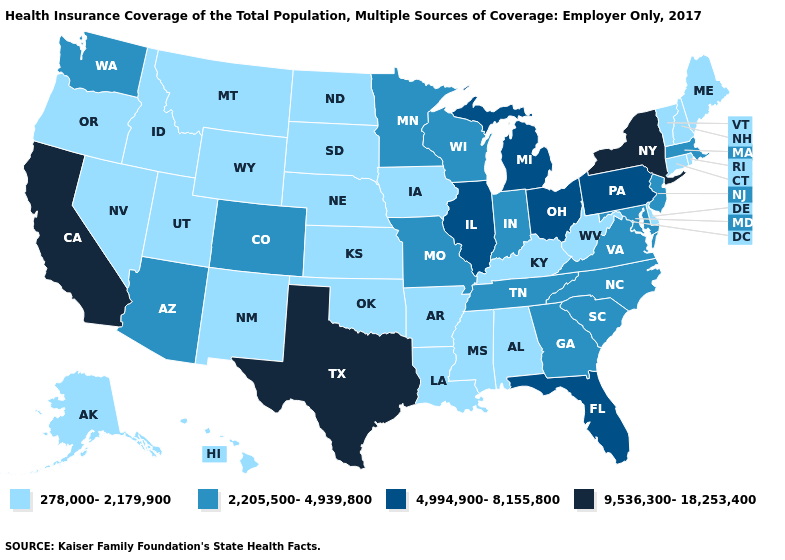Which states have the lowest value in the West?
Short answer required. Alaska, Hawaii, Idaho, Montana, Nevada, New Mexico, Oregon, Utah, Wyoming. Does Washington have the lowest value in the West?
Short answer required. No. Does Alaska have the highest value in the USA?
Keep it brief. No. Is the legend a continuous bar?
Short answer required. No. Which states have the lowest value in the South?
Short answer required. Alabama, Arkansas, Delaware, Kentucky, Louisiana, Mississippi, Oklahoma, West Virginia. Does Wyoming have the same value as Tennessee?
Give a very brief answer. No. Does Oklahoma have the same value as Oregon?
Short answer required. Yes. Name the states that have a value in the range 278,000-2,179,900?
Write a very short answer. Alabama, Alaska, Arkansas, Connecticut, Delaware, Hawaii, Idaho, Iowa, Kansas, Kentucky, Louisiana, Maine, Mississippi, Montana, Nebraska, Nevada, New Hampshire, New Mexico, North Dakota, Oklahoma, Oregon, Rhode Island, South Dakota, Utah, Vermont, West Virginia, Wyoming. Is the legend a continuous bar?
Give a very brief answer. No. What is the highest value in states that border Vermont?
Short answer required. 9,536,300-18,253,400. What is the highest value in the USA?
Write a very short answer. 9,536,300-18,253,400. Does the first symbol in the legend represent the smallest category?
Keep it brief. Yes. Among the states that border Pennsylvania , does Delaware have the lowest value?
Write a very short answer. Yes. Name the states that have a value in the range 2,205,500-4,939,800?
Short answer required. Arizona, Colorado, Georgia, Indiana, Maryland, Massachusetts, Minnesota, Missouri, New Jersey, North Carolina, South Carolina, Tennessee, Virginia, Washington, Wisconsin. Does New Mexico have the same value as California?
Give a very brief answer. No. 